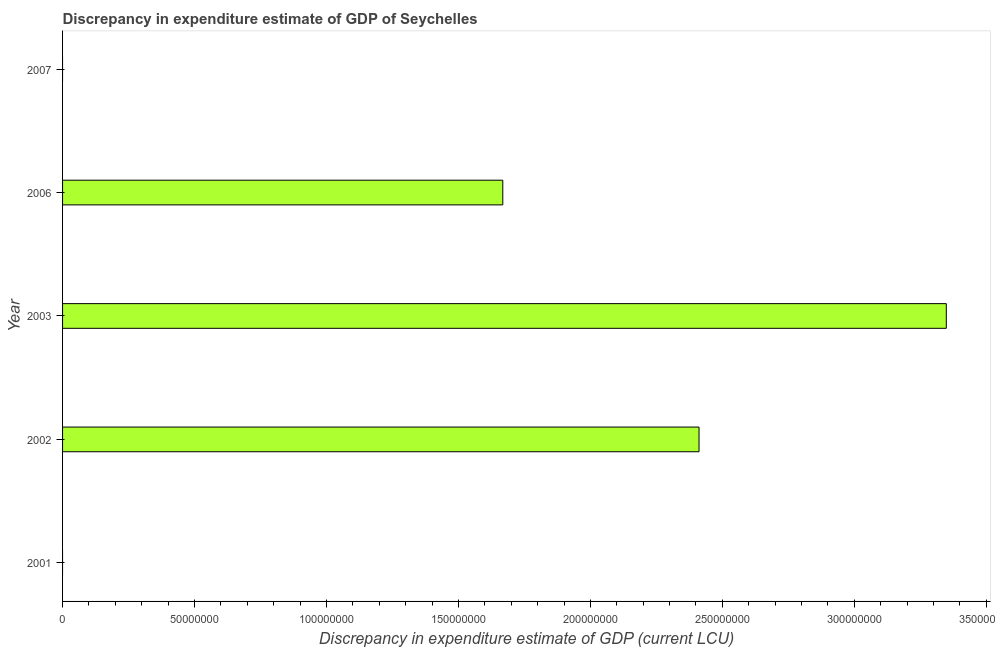Does the graph contain any zero values?
Keep it short and to the point. Yes. What is the title of the graph?
Make the answer very short. Discrepancy in expenditure estimate of GDP of Seychelles. What is the label or title of the X-axis?
Keep it short and to the point. Discrepancy in expenditure estimate of GDP (current LCU). What is the label or title of the Y-axis?
Your response must be concise. Year. What is the discrepancy in expenditure estimate of gdp in 2003?
Give a very brief answer. 3.35e+08. Across all years, what is the maximum discrepancy in expenditure estimate of gdp?
Your response must be concise. 3.35e+08. What is the sum of the discrepancy in expenditure estimate of gdp?
Provide a short and direct response. 7.43e+08. What is the difference between the discrepancy in expenditure estimate of gdp in 2002 and 2003?
Your response must be concise. -9.37e+07. What is the average discrepancy in expenditure estimate of gdp per year?
Your response must be concise. 1.49e+08. What is the median discrepancy in expenditure estimate of gdp?
Make the answer very short. 1.67e+08. In how many years, is the discrepancy in expenditure estimate of gdp greater than 300000000 LCU?
Give a very brief answer. 1. Is the discrepancy in expenditure estimate of gdp in 2002 less than that in 2003?
Ensure brevity in your answer.  Yes. Is the difference between the discrepancy in expenditure estimate of gdp in 2002 and 2003 greater than the difference between any two years?
Your answer should be very brief. No. What is the difference between the highest and the second highest discrepancy in expenditure estimate of gdp?
Your answer should be compact. 9.37e+07. Is the sum of the discrepancy in expenditure estimate of gdp in 2002 and 2006 greater than the maximum discrepancy in expenditure estimate of gdp across all years?
Your response must be concise. Yes. What is the difference between the highest and the lowest discrepancy in expenditure estimate of gdp?
Provide a short and direct response. 3.35e+08. In how many years, is the discrepancy in expenditure estimate of gdp greater than the average discrepancy in expenditure estimate of gdp taken over all years?
Give a very brief answer. 3. How many bars are there?
Your answer should be very brief. 3. Are all the bars in the graph horizontal?
Provide a short and direct response. Yes. How many years are there in the graph?
Keep it short and to the point. 5. What is the Discrepancy in expenditure estimate of GDP (current LCU) in 2001?
Make the answer very short. 0. What is the Discrepancy in expenditure estimate of GDP (current LCU) in 2002?
Provide a succinct answer. 2.41e+08. What is the Discrepancy in expenditure estimate of GDP (current LCU) in 2003?
Provide a short and direct response. 3.35e+08. What is the Discrepancy in expenditure estimate of GDP (current LCU) of 2006?
Offer a terse response. 1.67e+08. What is the Discrepancy in expenditure estimate of GDP (current LCU) in 2007?
Offer a very short reply. 0. What is the difference between the Discrepancy in expenditure estimate of GDP (current LCU) in 2002 and 2003?
Ensure brevity in your answer.  -9.37e+07. What is the difference between the Discrepancy in expenditure estimate of GDP (current LCU) in 2002 and 2006?
Your answer should be compact. 7.44e+07. What is the difference between the Discrepancy in expenditure estimate of GDP (current LCU) in 2003 and 2006?
Ensure brevity in your answer.  1.68e+08. What is the ratio of the Discrepancy in expenditure estimate of GDP (current LCU) in 2002 to that in 2003?
Provide a short and direct response. 0.72. What is the ratio of the Discrepancy in expenditure estimate of GDP (current LCU) in 2002 to that in 2006?
Your answer should be compact. 1.45. What is the ratio of the Discrepancy in expenditure estimate of GDP (current LCU) in 2003 to that in 2006?
Your response must be concise. 2.01. 